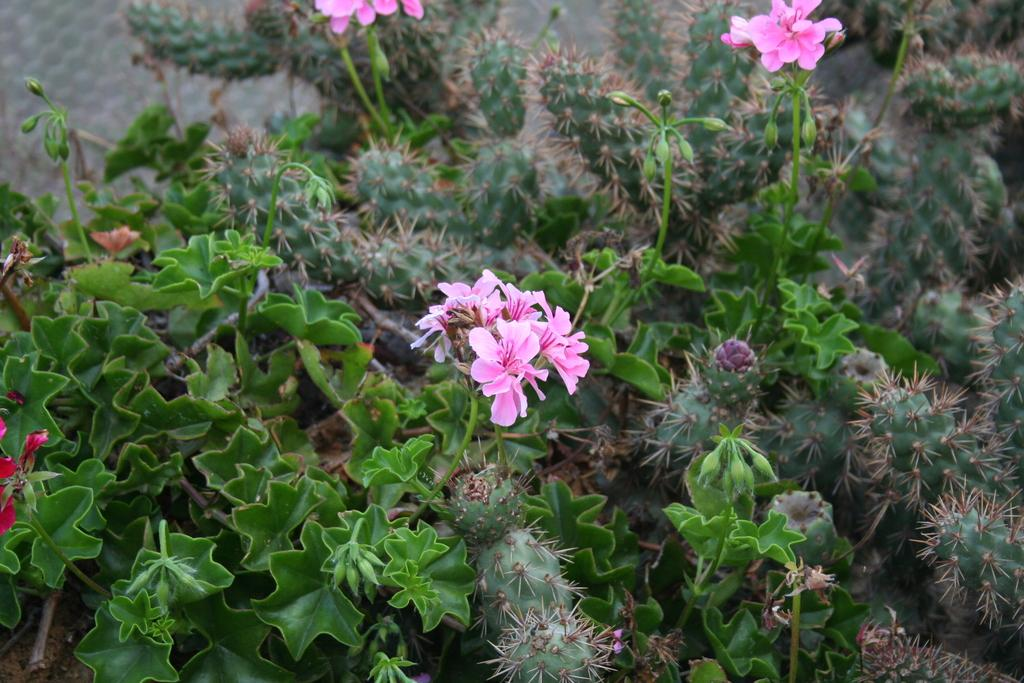What type of living organisms can be seen in the image? Plants can be seen in the image. What specific feature of the plants is visible? The plants have flowers. What type of creature can be seen talking to the plants in the image? There is no creature present in the image, and the plants do not talk. 